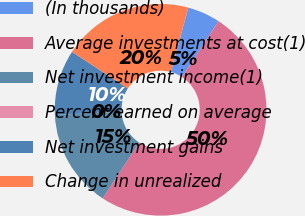Convert chart to OTSL. <chart><loc_0><loc_0><loc_500><loc_500><pie_chart><fcel>(In thousands)<fcel>Average investments at cost(1)<fcel>Net investment income(1)<fcel>Percent earned on average<fcel>Net investment gains<fcel>Change in unrealized<nl><fcel>5.0%<fcel>50.0%<fcel>15.0%<fcel>0.0%<fcel>10.0%<fcel>20.0%<nl></chart> 